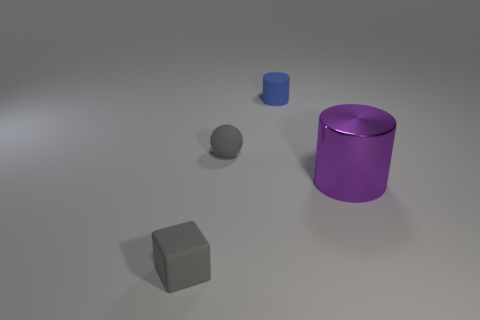Subtract all spheres. How many objects are left? 3 Subtract 1 cylinders. How many cylinders are left? 1 Add 4 gray cubes. How many objects exist? 8 Subtract all purple cylinders. How many cylinders are left? 1 Subtract all purple balls. How many blue cylinders are left? 1 Add 3 big purple objects. How many big purple objects are left? 4 Add 1 large objects. How many large objects exist? 2 Subtract 0 purple spheres. How many objects are left? 4 Subtract all red spheres. Subtract all yellow cylinders. How many spheres are left? 1 Subtract all tiny brown cubes. Subtract all small balls. How many objects are left? 3 